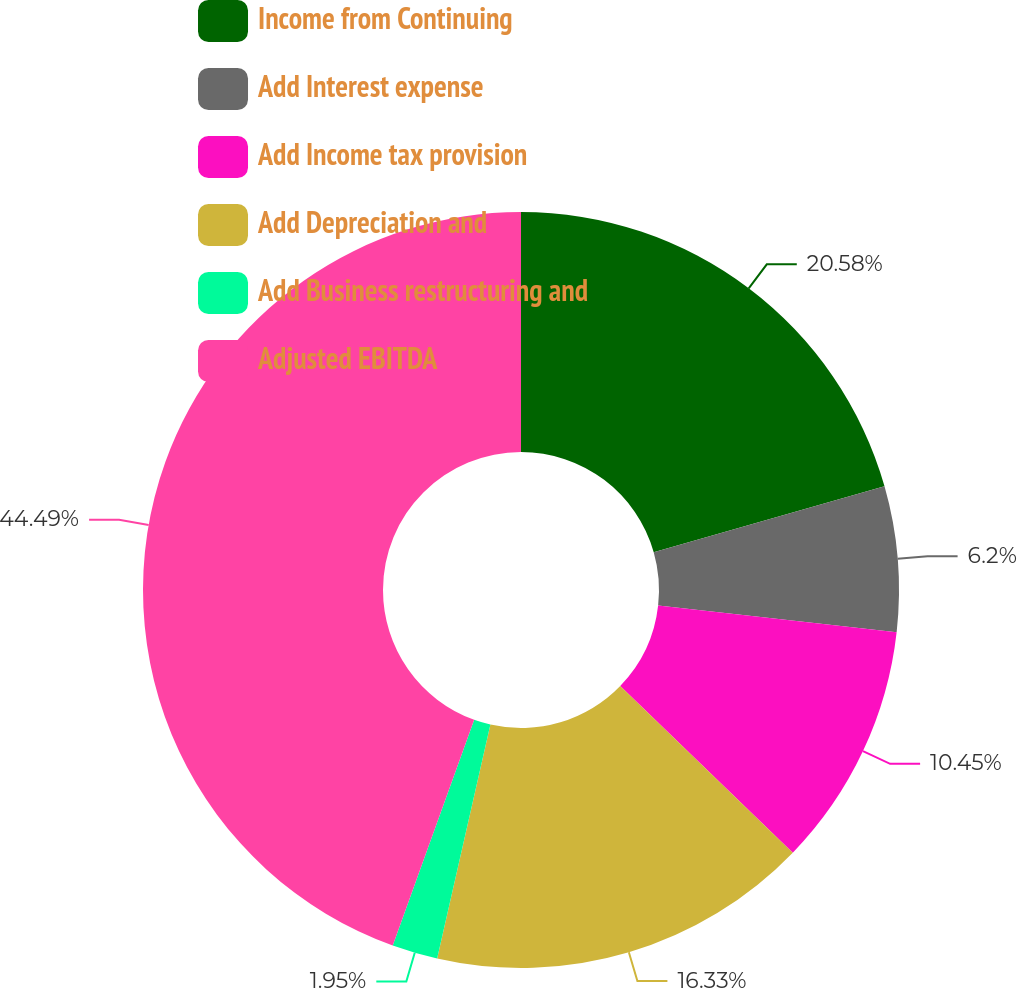Convert chart. <chart><loc_0><loc_0><loc_500><loc_500><pie_chart><fcel>Income from Continuing<fcel>Add Interest expense<fcel>Add Income tax provision<fcel>Add Depreciation and<fcel>Add Business restructuring and<fcel>Adjusted EBITDA<nl><fcel>20.58%<fcel>6.2%<fcel>10.45%<fcel>16.33%<fcel>1.95%<fcel>44.49%<nl></chart> 